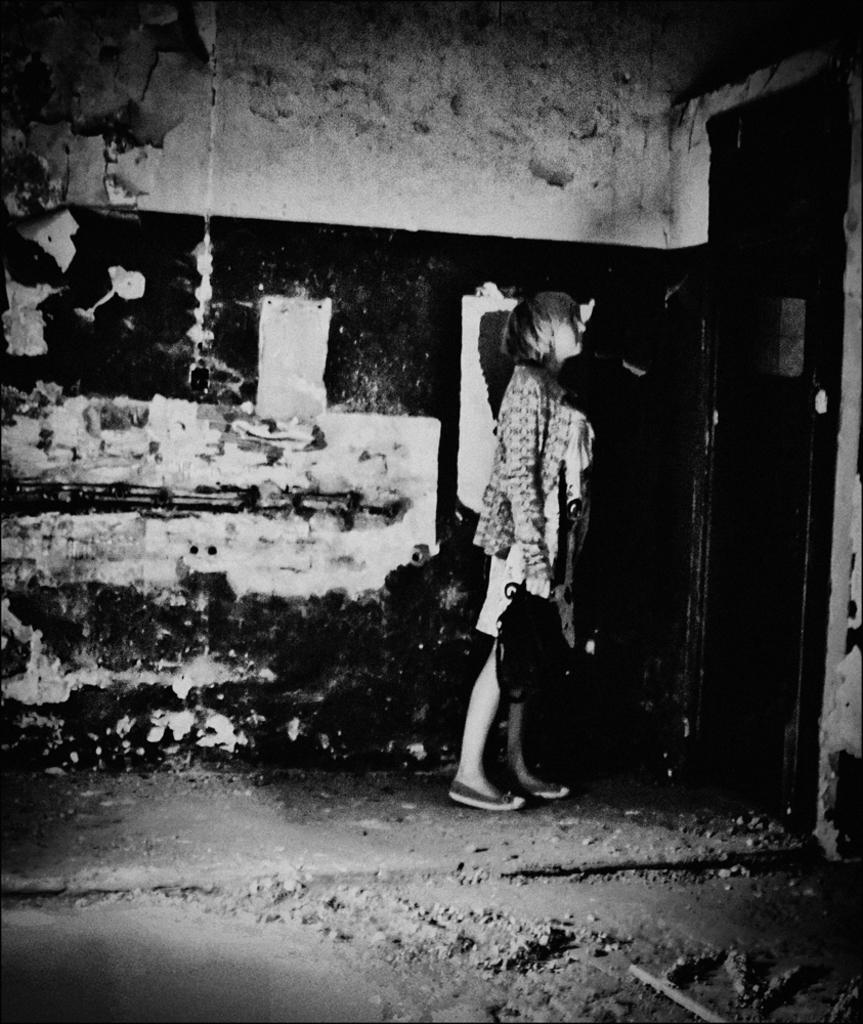What is the color scheme of the image? The image is black and white. What can be seen in the image? There is a person standing in the image. Where is the person standing? The person is standing on a floor. What is visible in the background of the image? There is a wall in the background of the image. How many times has the person whistled in the image? There is no whistling or indication of whistling in the image. What is the amount of development that can be seen in the image? The image does not depict any development or construction; it only shows a person standing in front of a wall. 